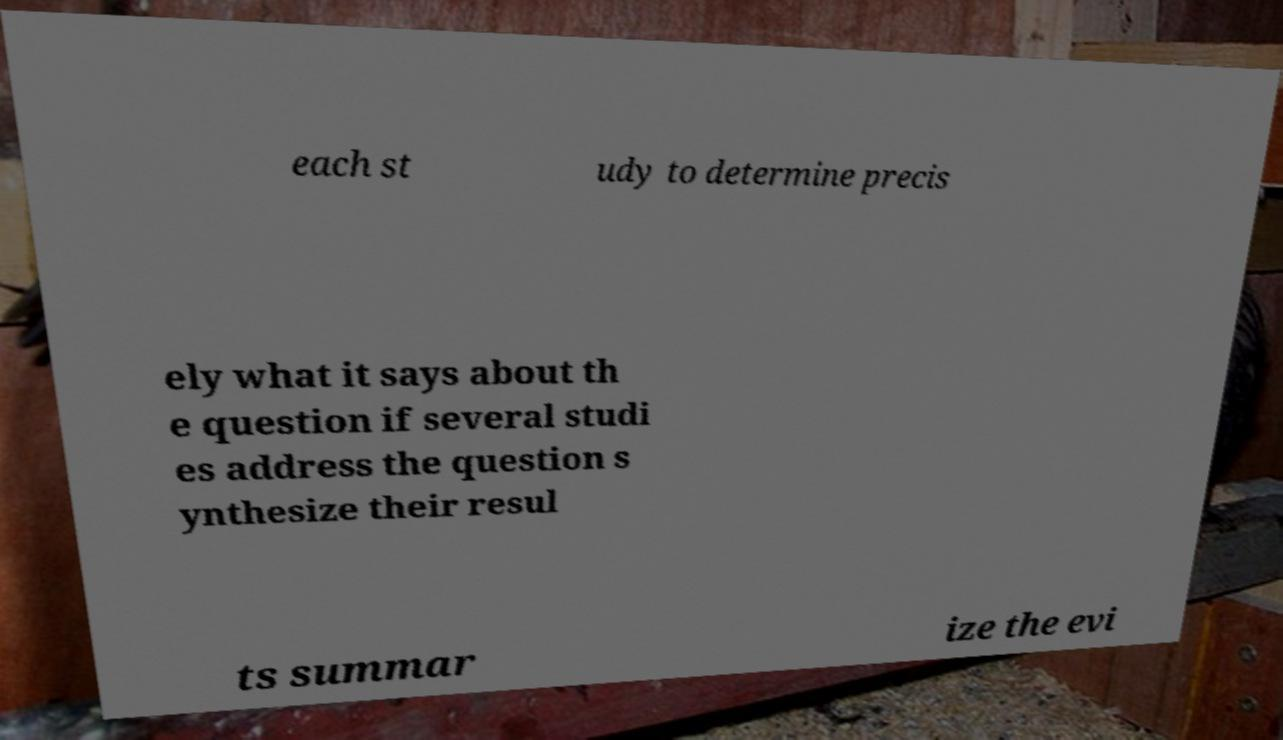Could you assist in decoding the text presented in this image and type it out clearly? each st udy to determine precis ely what it says about th e question if several studi es address the question s ynthesize their resul ts summar ize the evi 